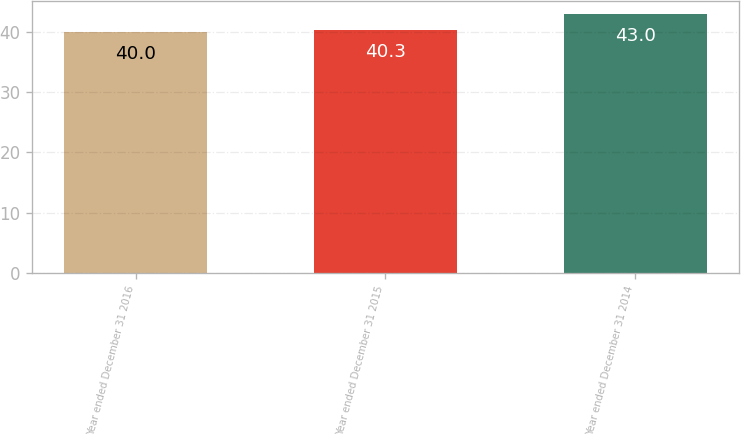Convert chart to OTSL. <chart><loc_0><loc_0><loc_500><loc_500><bar_chart><fcel>Year ended December 31 2016<fcel>Year ended December 31 2015<fcel>Year ended December 31 2014<nl><fcel>40<fcel>40.3<fcel>43<nl></chart> 